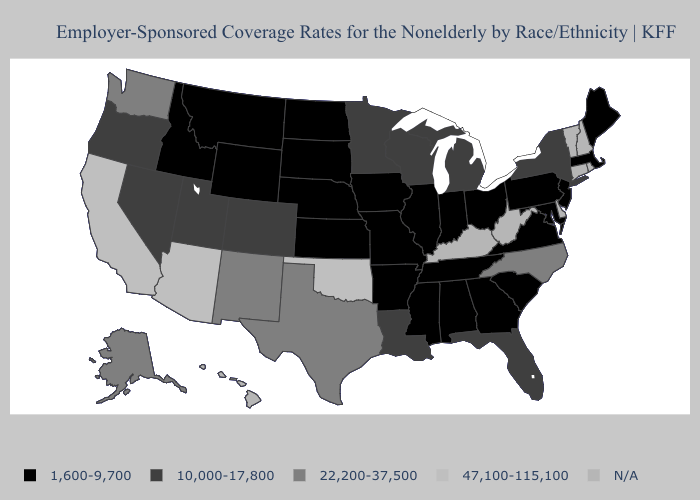Which states hav the highest value in the Northeast?
Answer briefly. New York. Name the states that have a value in the range 22,200-37,500?
Concise answer only. Alaska, New Mexico, North Carolina, Texas, Washington. Does the map have missing data?
Quick response, please. Yes. Is the legend a continuous bar?
Give a very brief answer. No. Which states have the highest value in the USA?
Keep it brief. Arizona, California, Oklahoma. Name the states that have a value in the range N/A?
Write a very short answer. Connecticut, Delaware, Hawaii, Kentucky, New Hampshire, Rhode Island, Vermont, West Virginia. Does Alaska have the lowest value in the USA?
Concise answer only. No. Does the map have missing data?
Quick response, please. Yes. Does the map have missing data?
Be succinct. Yes. Does Oklahoma have the highest value in the USA?
Quick response, please. Yes. Name the states that have a value in the range 22,200-37,500?
Write a very short answer. Alaska, New Mexico, North Carolina, Texas, Washington. Name the states that have a value in the range N/A?
Answer briefly. Connecticut, Delaware, Hawaii, Kentucky, New Hampshire, Rhode Island, Vermont, West Virginia. Name the states that have a value in the range 22,200-37,500?
Short answer required. Alaska, New Mexico, North Carolina, Texas, Washington. Name the states that have a value in the range 1,600-9,700?
Concise answer only. Alabama, Arkansas, Georgia, Idaho, Illinois, Indiana, Iowa, Kansas, Maine, Maryland, Massachusetts, Mississippi, Missouri, Montana, Nebraska, New Jersey, North Dakota, Ohio, Pennsylvania, South Carolina, South Dakota, Tennessee, Virginia, Wyoming. 